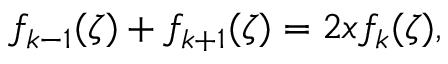<formula> <loc_0><loc_0><loc_500><loc_500>f _ { k - 1 } ( \zeta ) + f _ { k + 1 } ( \zeta ) = 2 x f _ { k } ( \zeta ) ,</formula> 